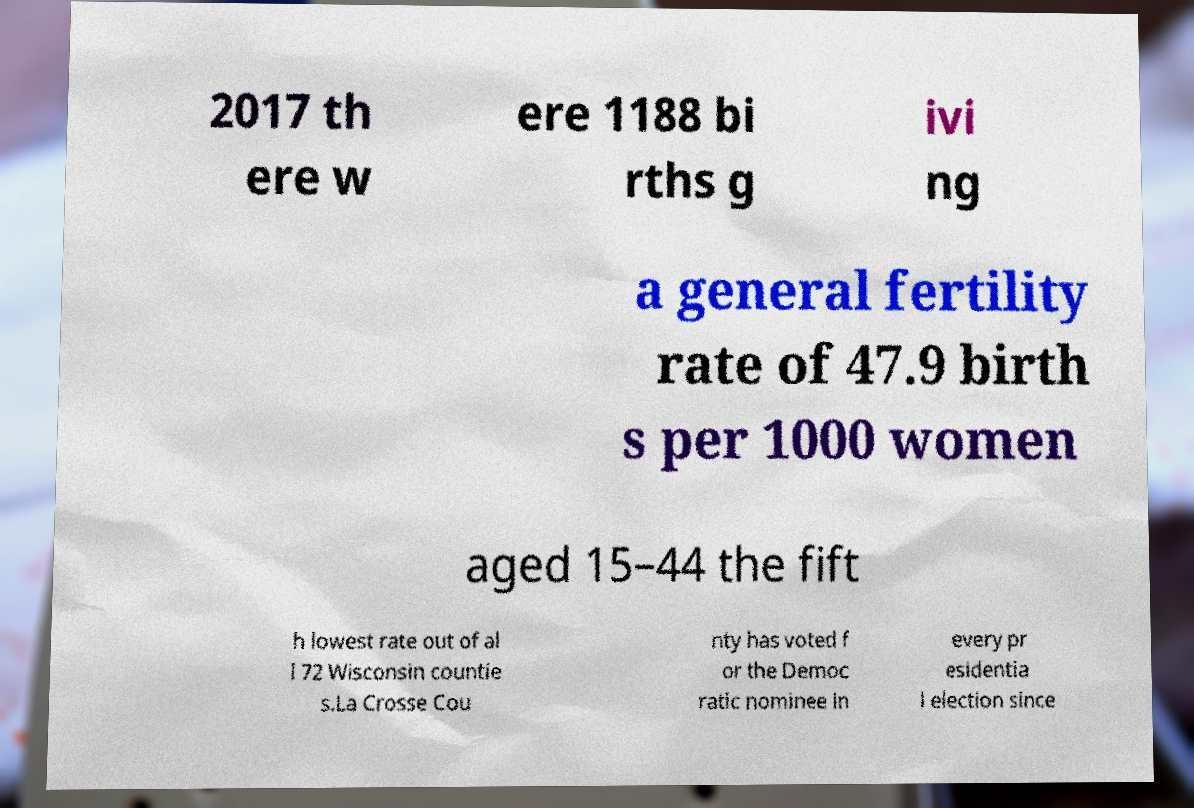I need the written content from this picture converted into text. Can you do that? 2017 th ere w ere 1188 bi rths g ivi ng a general fertility rate of 47.9 birth s per 1000 women aged 15–44 the fift h lowest rate out of al l 72 Wisconsin countie s.La Crosse Cou nty has voted f or the Democ ratic nominee in every pr esidentia l election since 